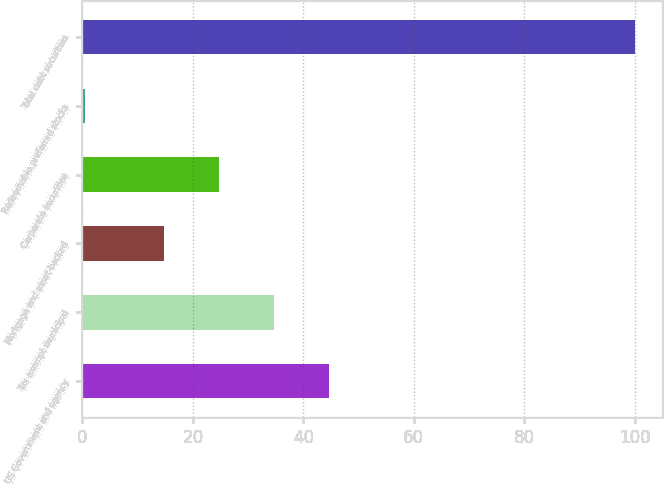<chart> <loc_0><loc_0><loc_500><loc_500><bar_chart><fcel>US Government and agency<fcel>Tax exempt municipal<fcel>Mortgage and asset-backed<fcel>Corporate securities<fcel>Redeemable preferred stocks<fcel>Total debt securities<nl><fcel>44.58<fcel>34.62<fcel>14.7<fcel>24.66<fcel>0.4<fcel>100<nl></chart> 